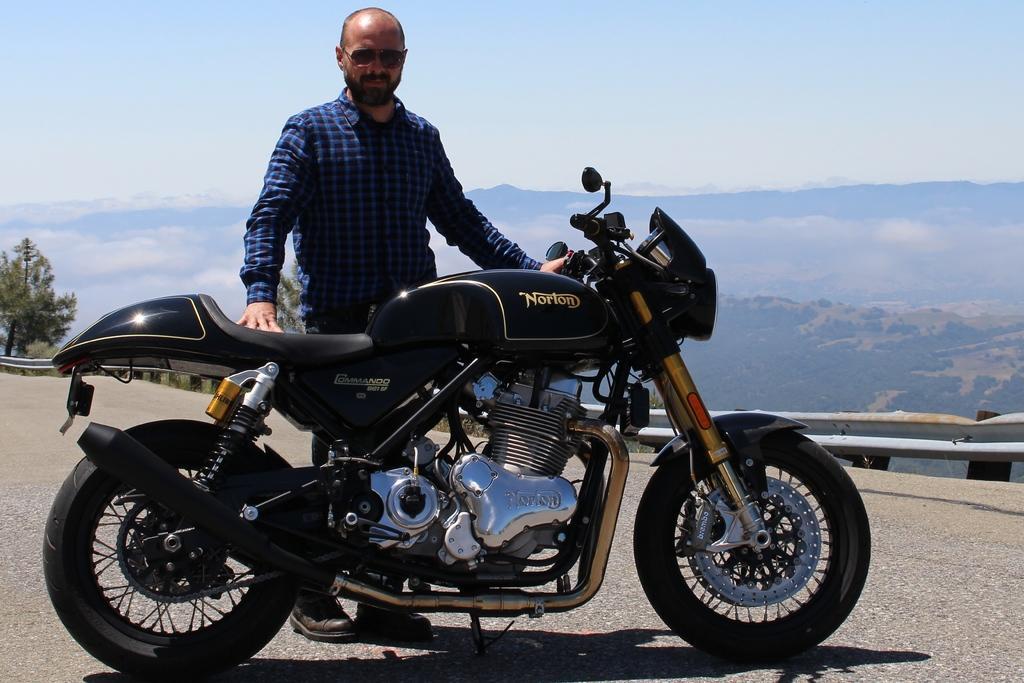How would you summarize this image in a sentence or two? In this picture there is a man who is standing behind the bike. Behind him I can see the road fencing. In the background I can see the clouds, trees and mountains. At the top I can see the sky. 